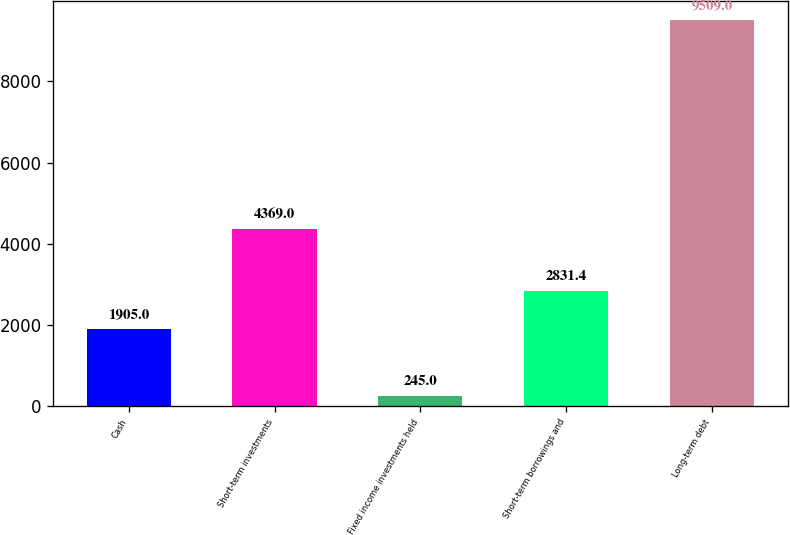<chart> <loc_0><loc_0><loc_500><loc_500><bar_chart><fcel>Cash<fcel>Short-term investments<fcel>Fixed income investments held<fcel>Short-term borrowings and<fcel>Long-term debt<nl><fcel>1905<fcel>4369<fcel>245<fcel>2831.4<fcel>9509<nl></chart> 